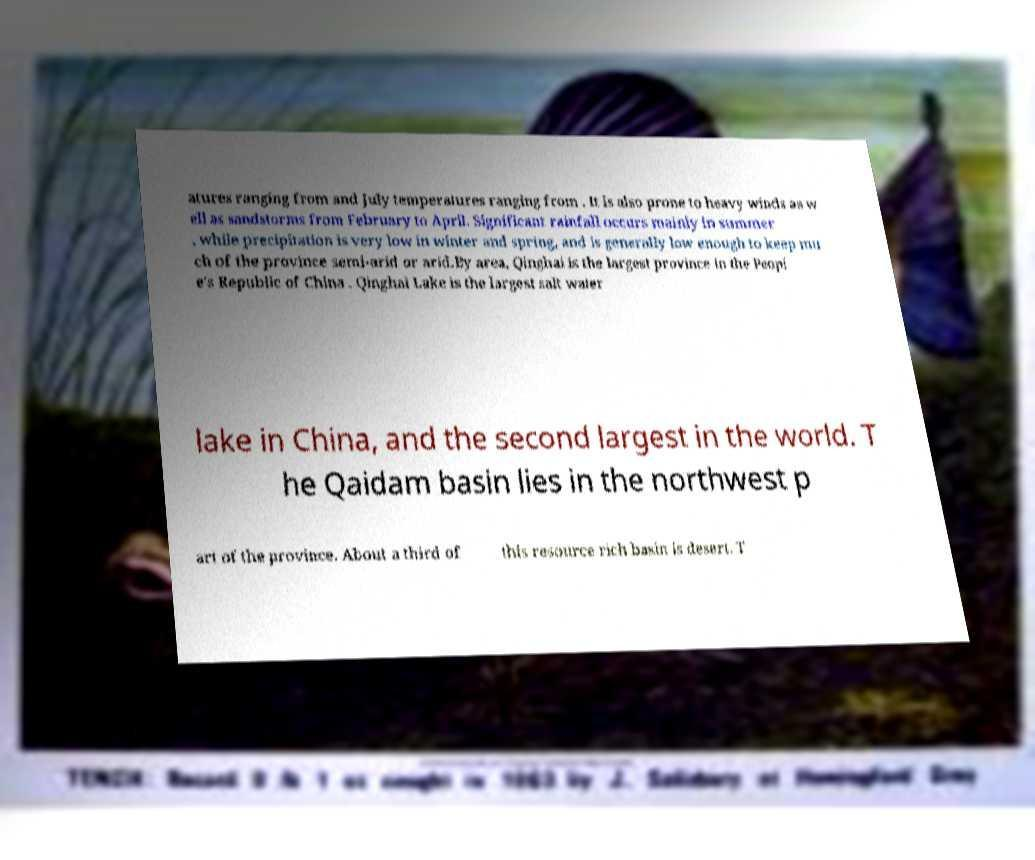Please identify and transcribe the text found in this image. atures ranging from and July temperatures ranging from . It is also prone to heavy winds as w ell as sandstorms from February to April. Significant rainfall occurs mainly in summer , while precipitation is very low in winter and spring, and is generally low enough to keep mu ch of the province semi-arid or arid.By area, Qinghai is the largest province in the Peopl e's Republic of China . Qinghai Lake is the largest salt water lake in China, and the second largest in the world. T he Qaidam basin lies in the northwest p art of the province. About a third of this resource rich basin is desert. T 